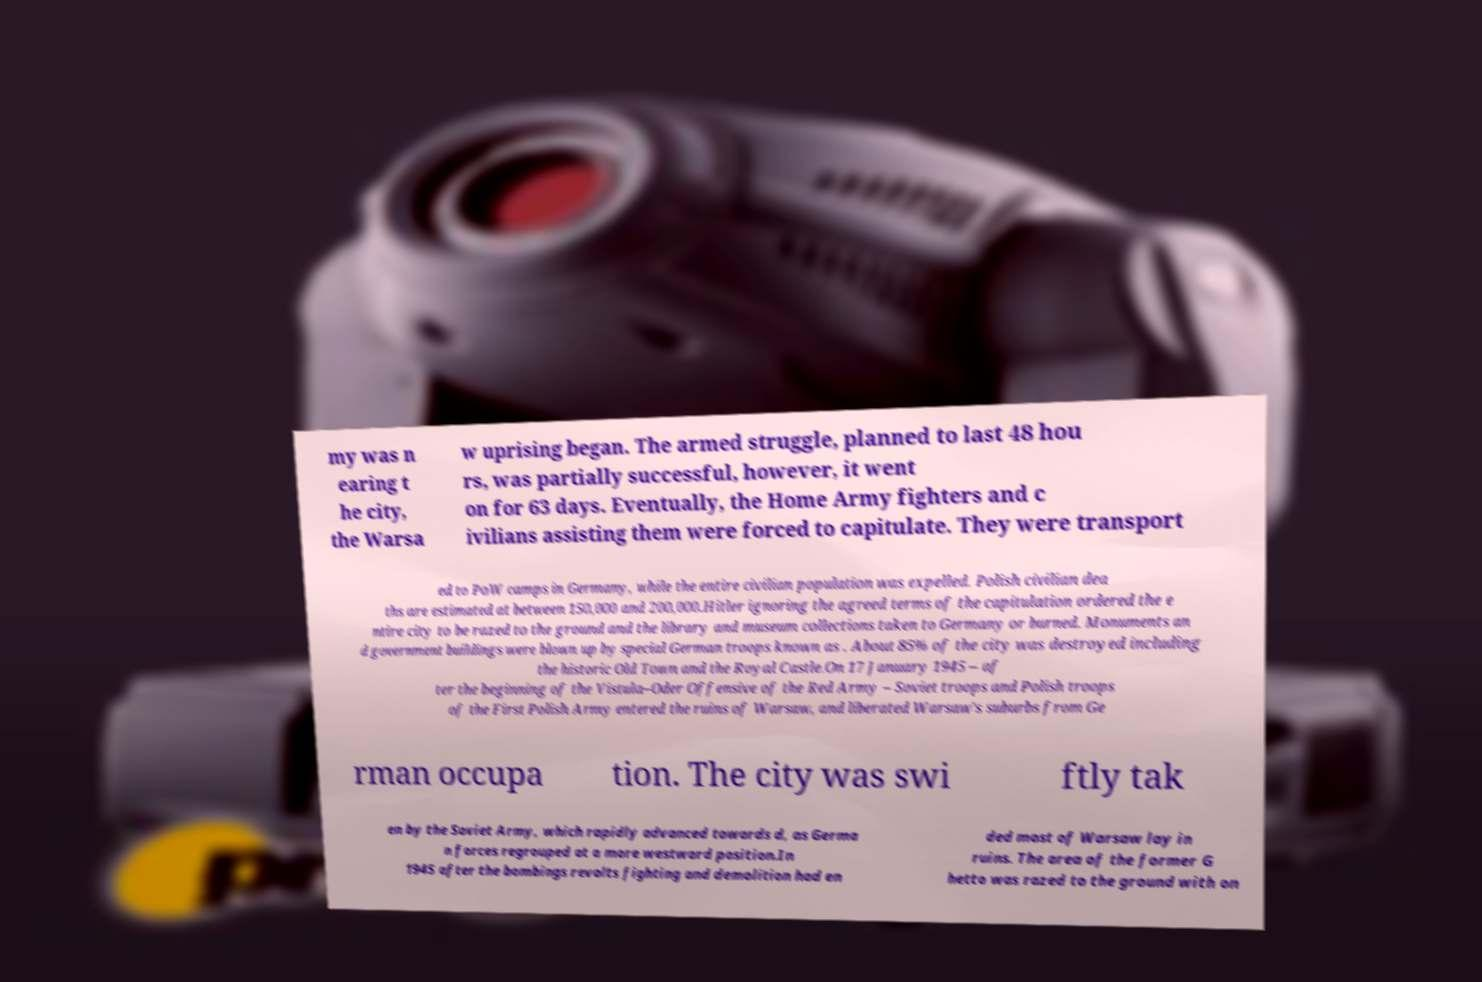For documentation purposes, I need the text within this image transcribed. Could you provide that? my was n earing t he city, the Warsa w uprising began. The armed struggle, planned to last 48 hou rs, was partially successful, however, it went on for 63 days. Eventually, the Home Army fighters and c ivilians assisting them were forced to capitulate. They were transport ed to PoW camps in Germany, while the entire civilian population was expelled. Polish civilian dea ths are estimated at between 150,000 and 200,000.Hitler ignoring the agreed terms of the capitulation ordered the e ntire city to be razed to the ground and the library and museum collections taken to Germany or burned. Monuments an d government buildings were blown up by special German troops known as . About 85% of the city was destroyed including the historic Old Town and the Royal Castle.On 17 January 1945 – af ter the beginning of the Vistula–Oder Offensive of the Red Army – Soviet troops and Polish troops of the First Polish Army entered the ruins of Warsaw, and liberated Warsaw's suburbs from Ge rman occupa tion. The city was swi ftly tak en by the Soviet Army, which rapidly advanced towards d, as Germa n forces regrouped at a more westward position.In 1945 after the bombings revolts fighting and demolition had en ded most of Warsaw lay in ruins. The area of the former G hetto was razed to the ground with on 